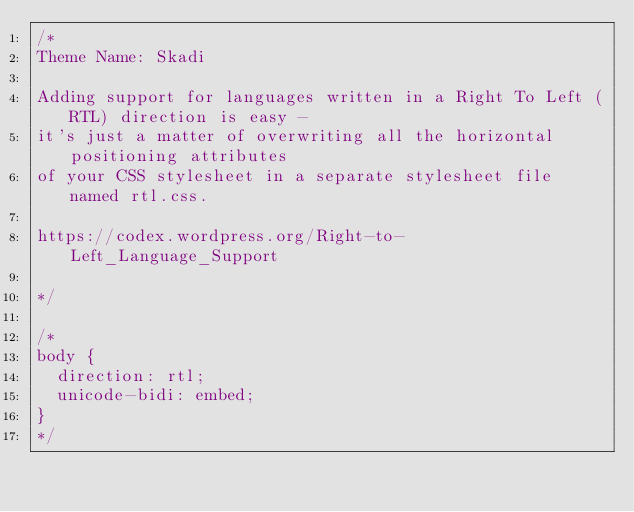Convert code to text. <code><loc_0><loc_0><loc_500><loc_500><_CSS_>/*
Theme Name: Skadi

Adding support for languages written in a Right To Left (RTL) direction is easy -
it's just a matter of overwriting all the horizontal positioning attributes
of your CSS stylesheet in a separate stylesheet file named rtl.css.

https://codex.wordpress.org/Right-to-Left_Language_Support

*/

/*
body {
	direction: rtl;
	unicode-bidi: embed;
}
*/
</code> 